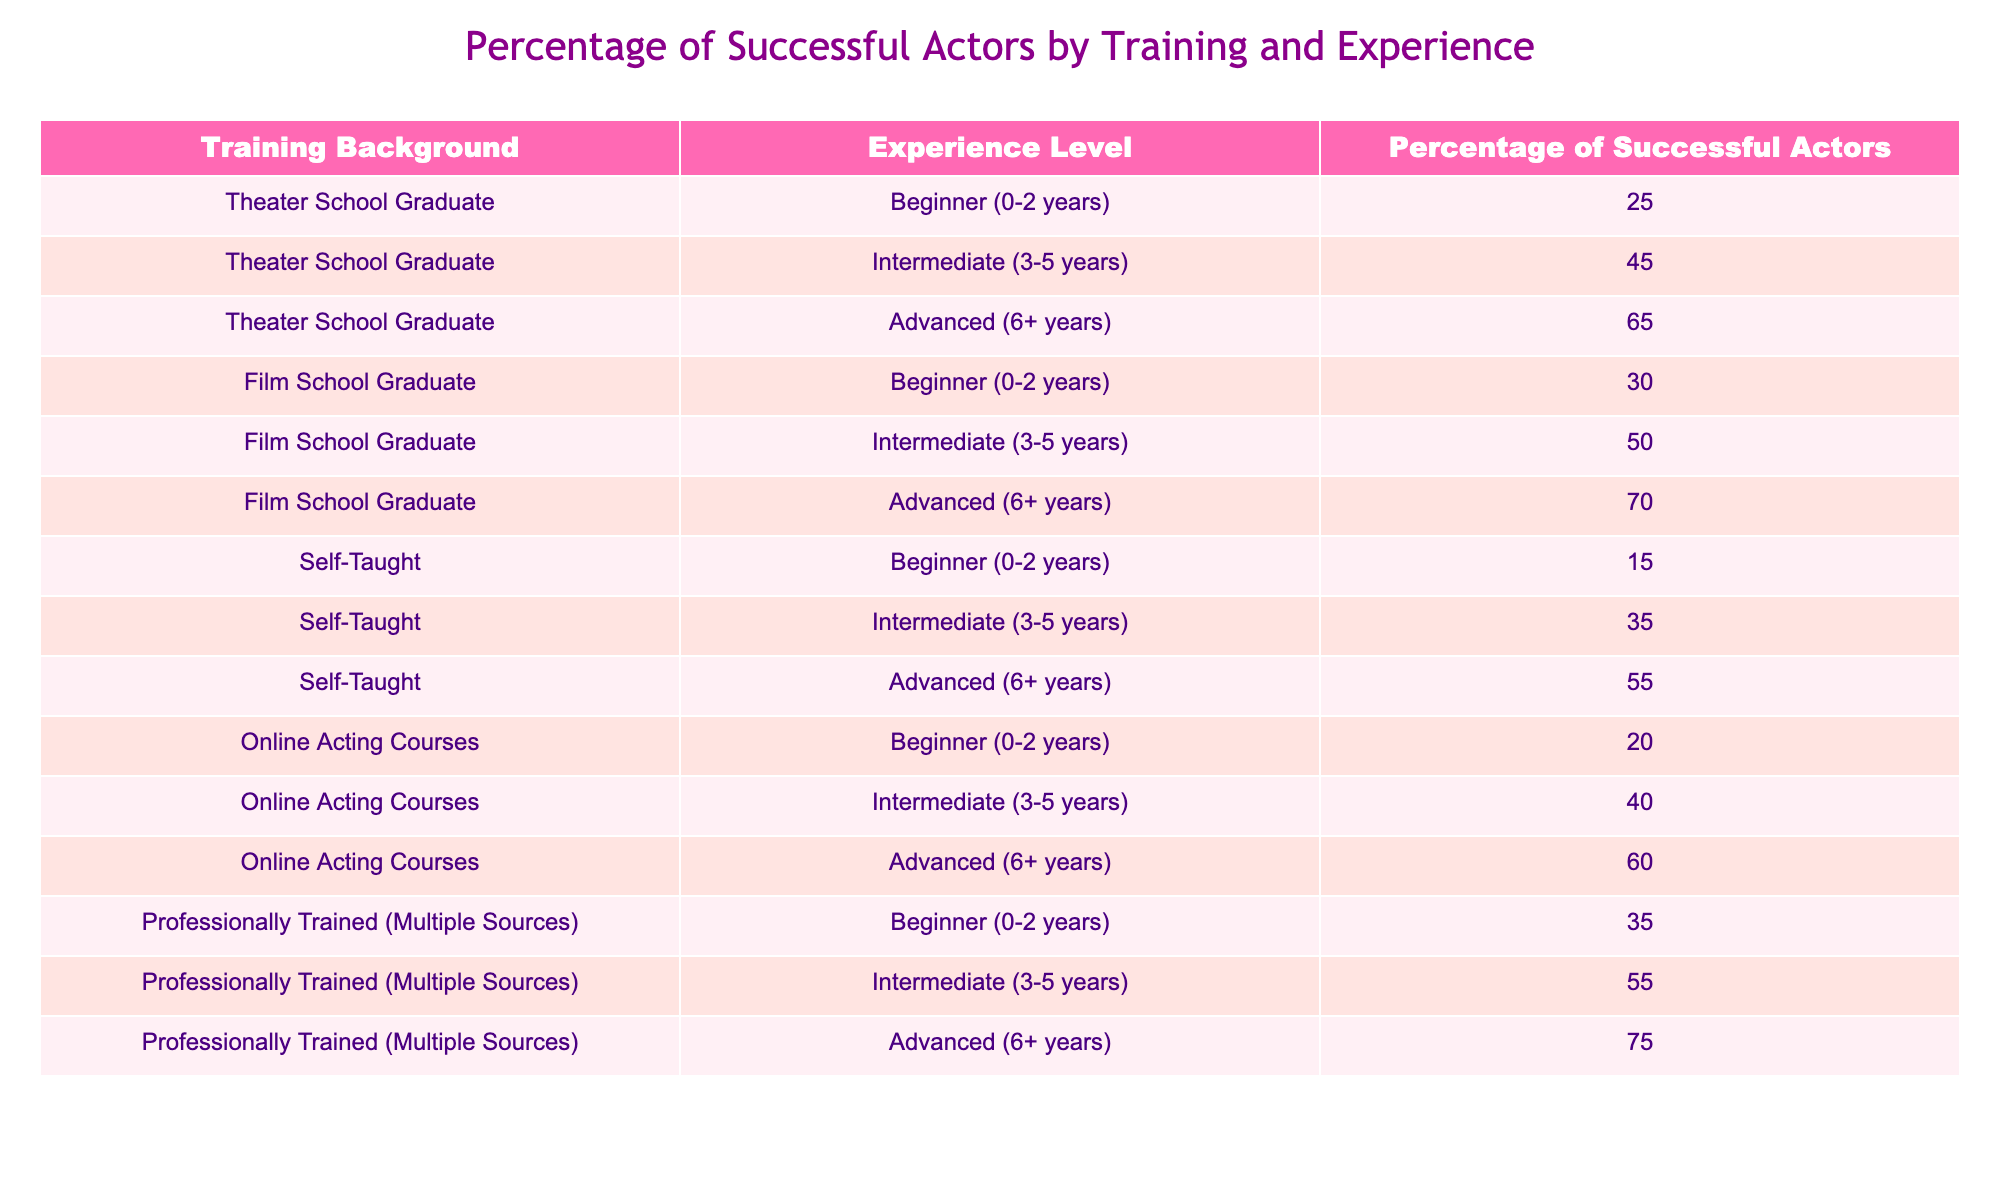What is the percentage of successful actors who are Theater School Graduates with advanced experience? According to the table, the percentage of successful actors who are Theater School Graduates with advanced experience (6+ years) is recorded as 65%
Answer: 65% Which training background has the highest percentage of successful advanced actors? To determine this, we can compare the percentages for advanced actors (6+ years) across all training backgrounds: Theater School Graduate (65%), Film School Graduate (70%), Self-Taught (55%), Online Acting Courses (60%), and Professionally Trained (Multiple Sources) (75%). The highest percentage is 75% for Professionally Trained (Multiple Sources).
Answer: 75% Is it true that Self-Taught actors have a higher success percentage at the intermediate level than those trained online? At the intermediate level (3-5 years), Self-Taught actors have a success percentage of 35%, while Online Acting Courses have a success percentage of 40%. Since 35% is less than 40%, the statement is false.
Answer: No What is the average percentage of successful actors for all training backgrounds at the beginner level? We need to calculate the average for the beginner level (0-2 years). The percentages are: Theater School Graduate (25%), Film School Graduate (30%), Self-Taught (15%), Online Acting Courses (20%), and Professionally Trained (Multiple Sources) (35%). Summing these gives 25 + 30 + 15 + 20 + 35 = 125. There are 5 data points, so the average is 125/5 = 25%.
Answer: 25% Do Film School Graduates at any experience level have a higher success percentage than Theater School Graduates? Checking the percentages: Theater School Graduates have 25% (beginner), 45% (intermediate), and 65% (advanced), while Film School Graduates have 30% (beginner), 50% (intermediate), and 70% (advanced). At every experience level, Film School Graduates have a higher percentage, confirming that the statement is true.
Answer: Yes Which experience level shows the largest percentage difference between Self-Taught and Professionally Trained actors? We compare the percentages for each experience level: Beginner (Self-Taught 15% - Professionally Trained 35% = -20%), Intermediate (Self-Taught 35% - Professionally Trained 55% = -20%), and Advanced (Self-Taught 55% - Professionally Trained 75% = -20%). All differences are the same, so the largest difference is 20% for all experience levels.
Answer: 20% 